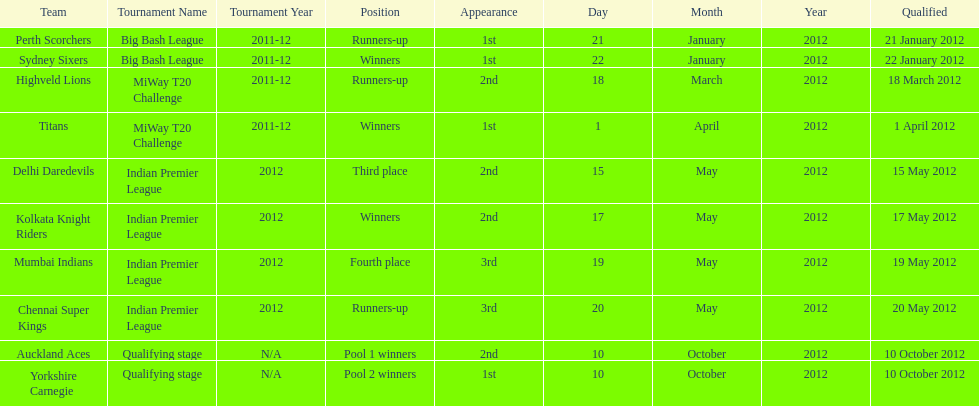The auckland aces and yorkshire carnegie qualified on what date? 10 October 2012. 